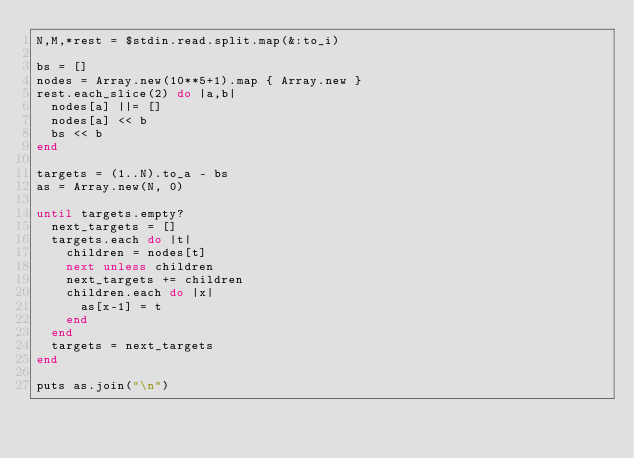<code> <loc_0><loc_0><loc_500><loc_500><_Ruby_>N,M,*rest = $stdin.read.split.map(&:to_i)

bs = []
nodes = Array.new(10**5+1).map { Array.new }
rest.each_slice(2) do |a,b|
  nodes[a] ||= []
  nodes[a] << b
  bs << b
end

targets = (1..N).to_a - bs
as = Array.new(N, 0)

until targets.empty?
  next_targets = []
  targets.each do |t|
    children = nodes[t]
    next unless children
    next_targets += children
    children.each do |x|
      as[x-1] = t
    end
  end
  targets = next_targets
end

puts as.join("\n")</code> 